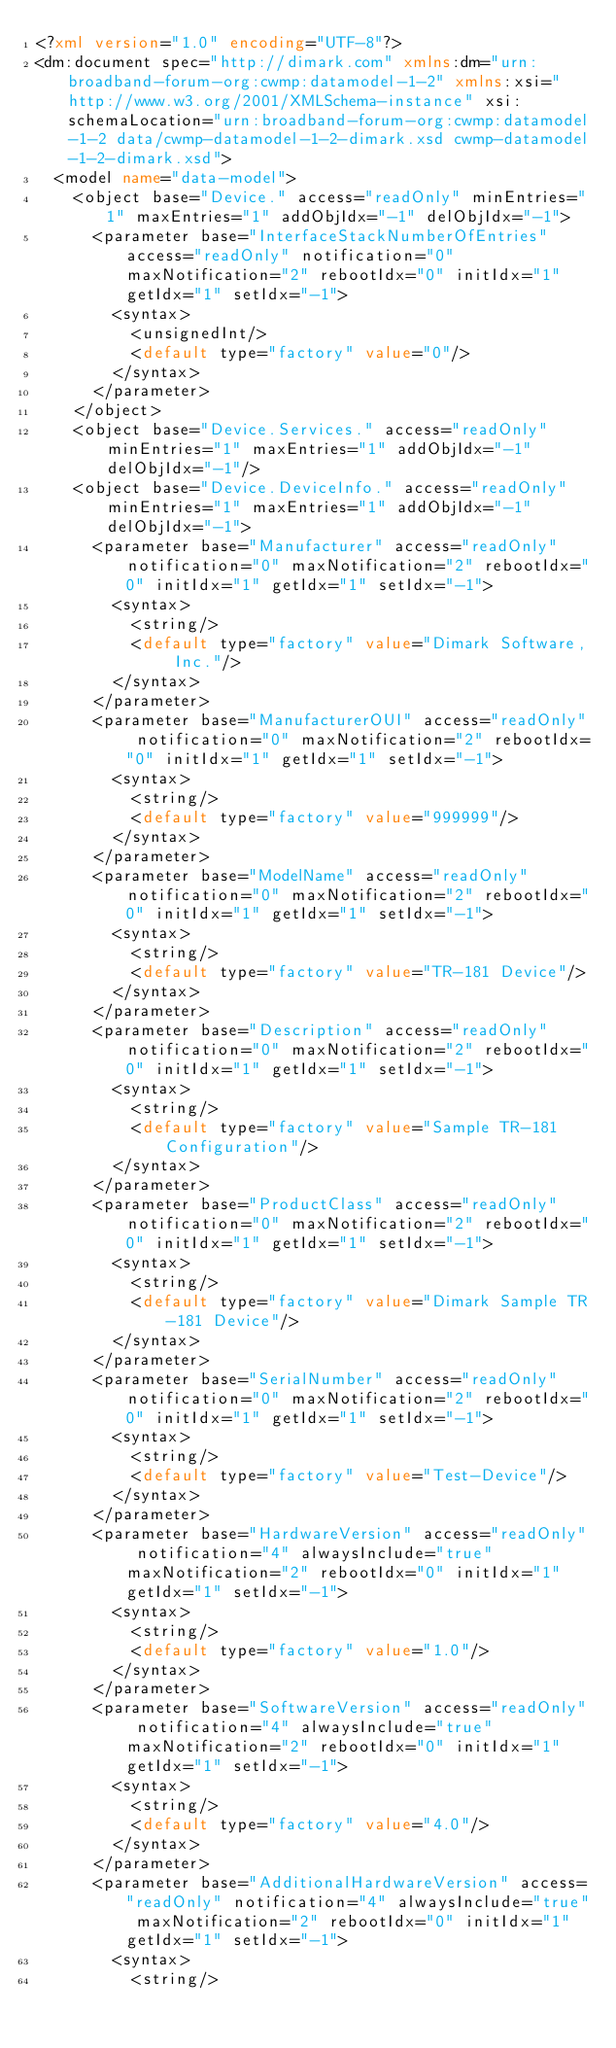<code> <loc_0><loc_0><loc_500><loc_500><_XML_><?xml version="1.0" encoding="UTF-8"?>
<dm:document spec="http://dimark.com" xmlns:dm="urn:broadband-forum-org:cwmp:datamodel-1-2" xmlns:xsi="http://www.w3.org/2001/XMLSchema-instance" xsi:schemaLocation="urn:broadband-forum-org:cwmp:datamodel-1-2 data/cwmp-datamodel-1-2-dimark.xsd cwmp-datamodel-1-2-dimark.xsd">
  <model name="data-model">
    <object base="Device." access="readOnly" minEntries="1" maxEntries="1" addObjIdx="-1" delObjIdx="-1">
      <parameter base="InterfaceStackNumberOfEntries" access="readOnly" notification="0" maxNotification="2" rebootIdx="0" initIdx="1" getIdx="1" setIdx="-1">
        <syntax>
          <unsignedInt/>
          <default type="factory" value="0"/>
        </syntax>
      </parameter>
    </object>    
    <object base="Device.Services." access="readOnly" minEntries="1" maxEntries="1" addObjIdx="-1" delObjIdx="-1"/>
    <object base="Device.DeviceInfo." access="readOnly" minEntries="1" maxEntries="1" addObjIdx="-1" delObjIdx="-1">
      <parameter base="Manufacturer" access="readOnly" notification="0" maxNotification="2" rebootIdx="0" initIdx="1" getIdx="1" setIdx="-1">
        <syntax>
          <string/>
          <default type="factory" value="Dimark Software, Inc."/>
        </syntax>
      </parameter>
      <parameter base="ManufacturerOUI" access="readOnly" notification="0" maxNotification="2" rebootIdx="0" initIdx="1" getIdx="1" setIdx="-1">
        <syntax>
          <string/>
          <default type="factory" value="999999"/>
        </syntax>
      </parameter>
      <parameter base="ModelName" access="readOnly" notification="0" maxNotification="2" rebootIdx="0" initIdx="1" getIdx="1" setIdx="-1">
        <syntax>
          <string/>
          <default type="factory" value="TR-181 Device"/>
        </syntax>
      </parameter>
      <parameter base="Description" access="readOnly" notification="0" maxNotification="2" rebootIdx="0" initIdx="1" getIdx="1" setIdx="-1">
        <syntax>
          <string/>
          <default type="factory" value="Sample TR-181 Configuration"/>
        </syntax>
      </parameter>
      <parameter base="ProductClass" access="readOnly" notification="0" maxNotification="2" rebootIdx="0" initIdx="1" getIdx="1" setIdx="-1">
        <syntax>
          <string/>
          <default type="factory" value="Dimark Sample TR-181 Device"/>
        </syntax>
      </parameter>
      <parameter base="SerialNumber" access="readOnly" notification="0" maxNotification="2" rebootIdx="0" initIdx="1" getIdx="1" setIdx="-1">
        <syntax>
          <string/>
          <default type="factory" value="Test-Device"/>
        </syntax>
      </parameter>
      <parameter base="HardwareVersion" access="readOnly" notification="4" alwaysInclude="true" maxNotification="2" rebootIdx="0" initIdx="1" getIdx="1" setIdx="-1">
        <syntax>
          <string/>
          <default type="factory" value="1.0"/>
        </syntax>
      </parameter>
      <parameter base="SoftwareVersion" access="readOnly" notification="4" alwaysInclude="true" maxNotification="2" rebootIdx="0" initIdx="1" getIdx="1" setIdx="-1">
        <syntax>
          <string/>
          <default type="factory" value="4.0"/>
        </syntax>
      </parameter>
	  <parameter base="AdditionalHardwareVersion" access="readOnly" notification="4" alwaysInclude="true" maxNotification="2" rebootIdx="0" initIdx="1" getIdx="1" setIdx="-1">
        <syntax>
          <string/></code> 